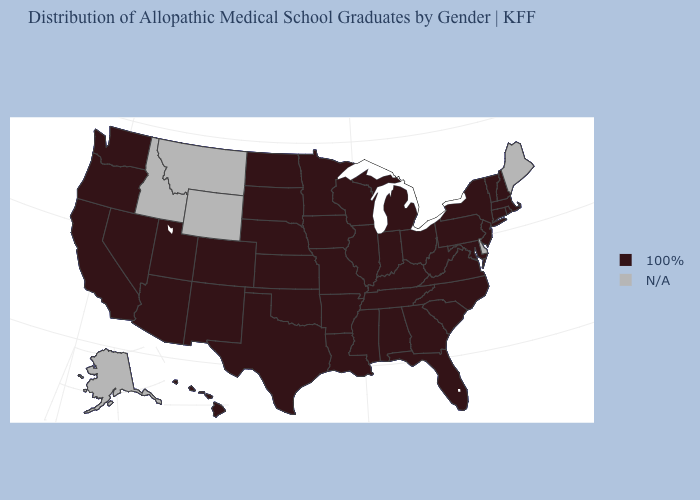Among the states that border Utah , which have the highest value?
Be succinct. Arizona, Colorado, Nevada, New Mexico. What is the value of Nebraska?
Keep it brief. 100%. Which states have the highest value in the USA?
Write a very short answer. Alabama, Arizona, Arkansas, California, Colorado, Connecticut, Florida, Georgia, Hawaii, Illinois, Indiana, Iowa, Kansas, Kentucky, Louisiana, Maryland, Massachusetts, Michigan, Minnesota, Mississippi, Missouri, Nebraska, Nevada, New Hampshire, New Jersey, New Mexico, New York, North Carolina, North Dakota, Ohio, Oklahoma, Oregon, Pennsylvania, Rhode Island, South Carolina, South Dakota, Tennessee, Texas, Utah, Vermont, Virginia, Washington, West Virginia, Wisconsin. What is the value of Utah?
Answer briefly. 100%. Name the states that have a value in the range N/A?
Be succinct. Alaska, Delaware, Idaho, Maine, Montana, Wyoming. Is the legend a continuous bar?
Be succinct. No. Is the legend a continuous bar?
Write a very short answer. No. Among the states that border South Dakota , which have the highest value?
Keep it brief. Iowa, Minnesota, Nebraska, North Dakota. Name the states that have a value in the range N/A?
Quick response, please. Alaska, Delaware, Idaho, Maine, Montana, Wyoming. Name the states that have a value in the range N/A?
Concise answer only. Alaska, Delaware, Idaho, Maine, Montana, Wyoming. Name the states that have a value in the range N/A?
Keep it brief. Alaska, Delaware, Idaho, Maine, Montana, Wyoming. Name the states that have a value in the range 100%?
Keep it brief. Alabama, Arizona, Arkansas, California, Colorado, Connecticut, Florida, Georgia, Hawaii, Illinois, Indiana, Iowa, Kansas, Kentucky, Louisiana, Maryland, Massachusetts, Michigan, Minnesota, Mississippi, Missouri, Nebraska, Nevada, New Hampshire, New Jersey, New Mexico, New York, North Carolina, North Dakota, Ohio, Oklahoma, Oregon, Pennsylvania, Rhode Island, South Carolina, South Dakota, Tennessee, Texas, Utah, Vermont, Virginia, Washington, West Virginia, Wisconsin. 